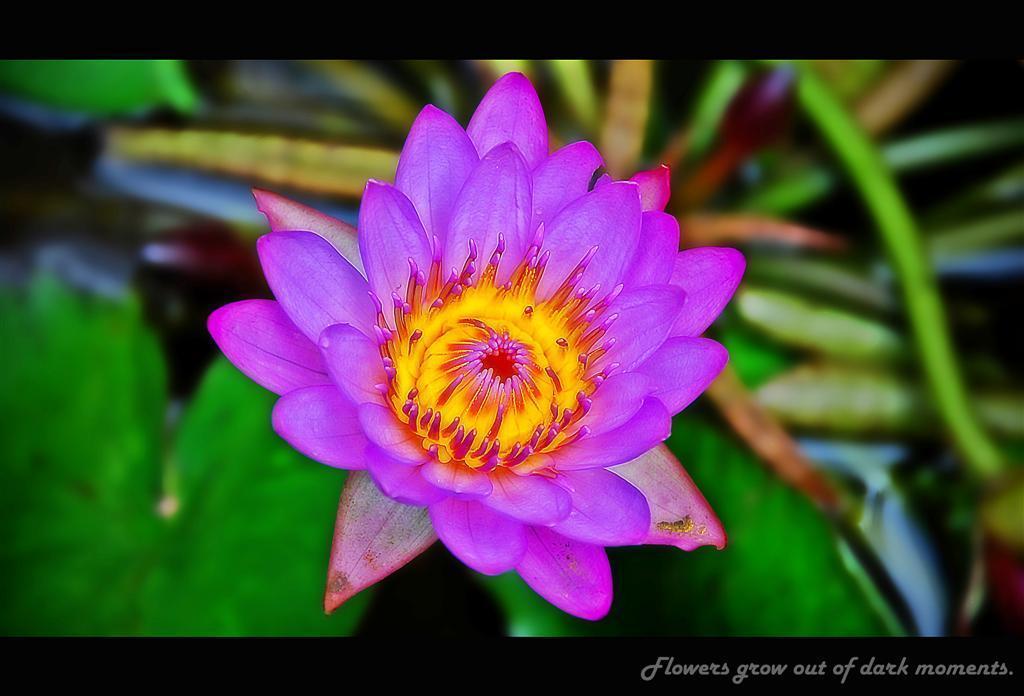Could you give a brief overview of what you see in this image? We can see flower. In the background it is green. In the bottom right side of the image we can see text. 